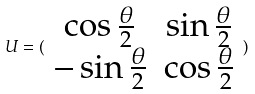<formula> <loc_0><loc_0><loc_500><loc_500>U = ( \begin{array} { c c } \cos \frac { \theta } { 2 } & \sin \frac { \theta } { 2 } \\ - \sin \frac { \theta } { 2 } & \cos \frac { \theta } { 2 } \end{array} )</formula> 